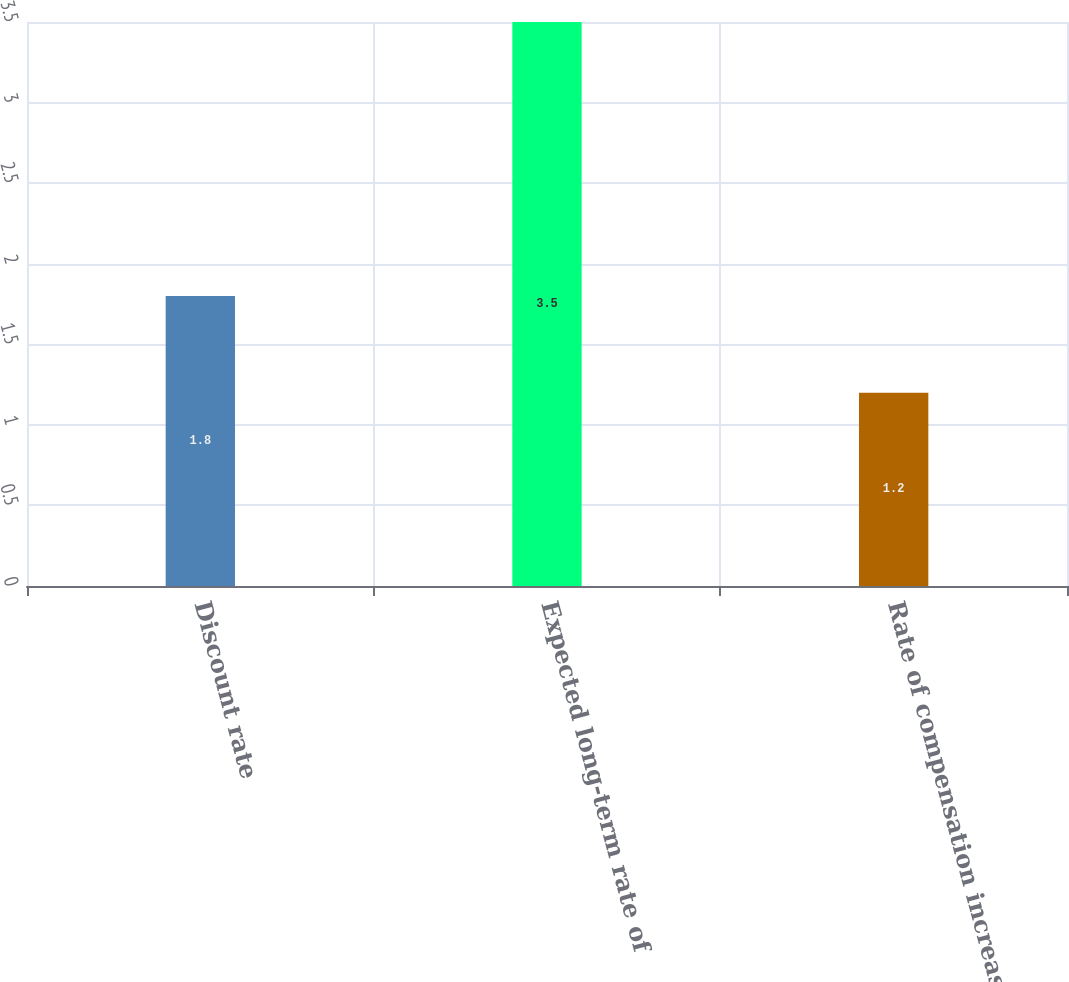<chart> <loc_0><loc_0><loc_500><loc_500><bar_chart><fcel>Discount rate<fcel>Expected long-term rate of<fcel>Rate of compensation increase<nl><fcel>1.8<fcel>3.5<fcel>1.2<nl></chart> 